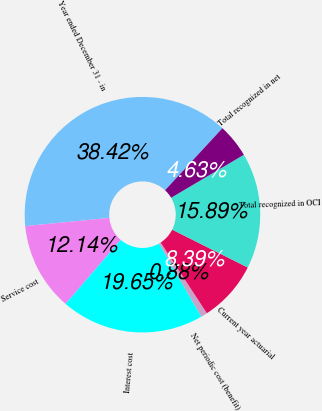Convert chart. <chart><loc_0><loc_0><loc_500><loc_500><pie_chart><fcel>Year ended December 31 - in<fcel>Service cost<fcel>Interest cost<fcel>Net periodic cost (benefit)<fcel>Current year actuarial<fcel>Total recognized in OCI<fcel>Total recognized in net<nl><fcel>38.42%<fcel>12.14%<fcel>19.65%<fcel>0.88%<fcel>8.39%<fcel>15.89%<fcel>4.63%<nl></chart> 